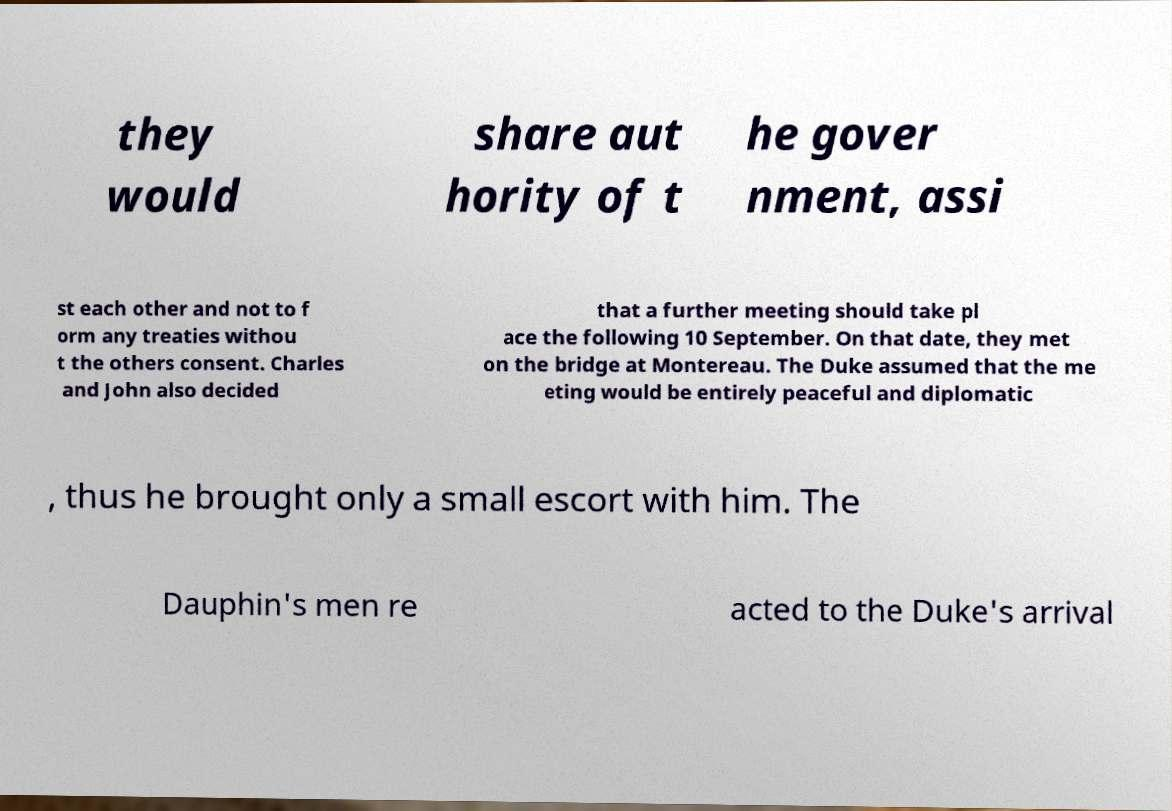What messages or text are displayed in this image? I need them in a readable, typed format. they would share aut hority of t he gover nment, assi st each other and not to f orm any treaties withou t the others consent. Charles and John also decided that a further meeting should take pl ace the following 10 September. On that date, they met on the bridge at Montereau. The Duke assumed that the me eting would be entirely peaceful and diplomatic , thus he brought only a small escort with him. The Dauphin's men re acted to the Duke's arrival 